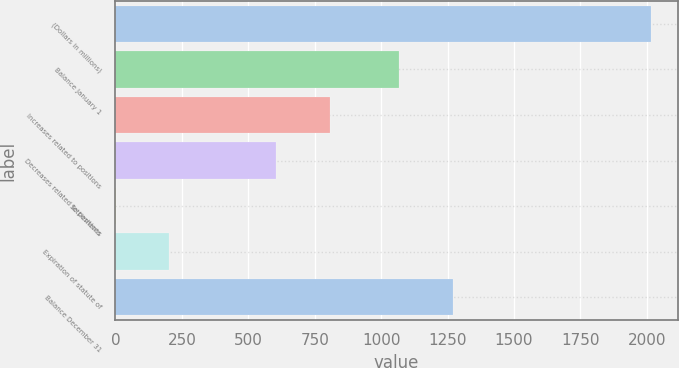Convert chart to OTSL. <chart><loc_0><loc_0><loc_500><loc_500><bar_chart><fcel>(Dollars in millions)<fcel>Balance January 1<fcel>Increases related to positions<fcel>Decreases related to positions<fcel>Settlements<fcel>Expiration of statute of<fcel>Balance December 31<nl><fcel>2015<fcel>1068<fcel>806.6<fcel>605.2<fcel>1<fcel>202.4<fcel>1269.4<nl></chart> 